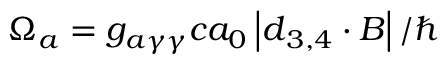Convert formula to latex. <formula><loc_0><loc_0><loc_500><loc_500>\Omega _ { a } = g _ { a \gamma \gamma } c a _ { 0 } \left | \boldsymbol d _ { 3 , 4 } \cdot \boldsymbol B \right | / \hbar</formula> 